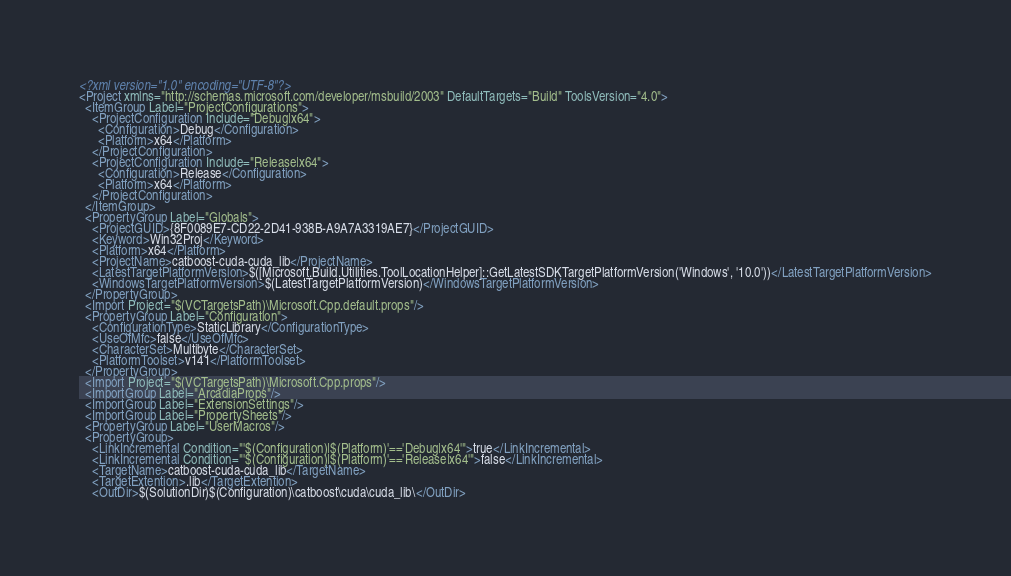<code> <loc_0><loc_0><loc_500><loc_500><_XML_><?xml version="1.0" encoding="UTF-8"?>
<Project xmlns="http://schemas.microsoft.com/developer/msbuild/2003" DefaultTargets="Build" ToolsVersion="4.0">
  <ItemGroup Label="ProjectConfigurations">
    <ProjectConfiguration Include="Debug|x64">
      <Configuration>Debug</Configuration>
      <Platform>x64</Platform>
    </ProjectConfiguration>
    <ProjectConfiguration Include="Release|x64">
      <Configuration>Release</Configuration>
      <Platform>x64</Platform>
    </ProjectConfiguration>
  </ItemGroup>
  <PropertyGroup Label="Globals">
    <ProjectGUID>{8F0089E7-CD22-2D41-938B-A9A7A3319AE7}</ProjectGUID>
    <Keyword>Win32Proj</Keyword>
    <Platform>x64</Platform>
    <ProjectName>catboost-cuda-cuda_lib</ProjectName>
    <LatestTargetPlatformVersion>$([Microsoft.Build.Utilities.ToolLocationHelper]::GetLatestSDKTargetPlatformVersion('Windows', '10.0'))</LatestTargetPlatformVersion>
    <WindowsTargetPlatformVersion>$(LatestTargetPlatformVersion)</WindowsTargetPlatformVersion>
  </PropertyGroup>
  <Import Project="$(VCTargetsPath)\Microsoft.Cpp.default.props"/>
  <PropertyGroup Label="Configuration">
    <ConfigurationType>StaticLibrary</ConfigurationType>
    <UseOfMfc>false</UseOfMfc>
    <CharacterSet>Multibyte</CharacterSet>
    <PlatformToolset>v141</PlatformToolset>
  </PropertyGroup>
  <Import Project="$(VCTargetsPath)\Microsoft.Cpp.props"/>
  <ImportGroup Label="ArcadiaProps"/>
  <ImportGroup Label="ExtensionSettings"/>
  <ImportGroup Label="PropertySheets"/>
  <PropertyGroup Label="UserMacros"/>
  <PropertyGroup>
    <LinkIncremental Condition="'$(Configuration)|$(Platform)'=='Debug|x64'">true</LinkIncremental>
    <LinkIncremental Condition="'$(Configuration)|$(Platform)'=='Release|x64'">false</LinkIncremental>
    <TargetName>catboost-cuda-cuda_lib</TargetName>
    <TargetExtention>.lib</TargetExtention>
    <OutDir>$(SolutionDir)$(Configuration)\catboost\cuda\cuda_lib\</OutDir></code> 